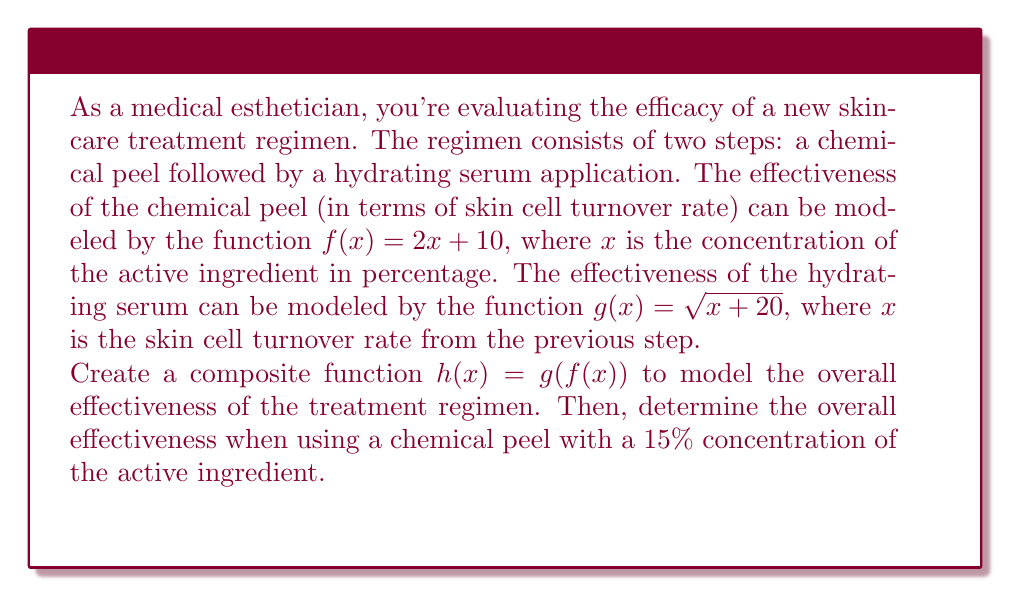What is the answer to this math problem? Let's approach this step-by-step:

1) We're given two functions:
   $f(x) = 2x + 10$ (chemical peel effectiveness)
   $g(x) = \sqrt{x + 20}$ (hydrating serum effectiveness)

2) We need to create a composite function $h(x) = g(f(x))$. This means we replace every $x$ in $g(x)$ with $f(x)$:

   $h(x) = g(f(x)) = \sqrt{f(x) + 20}$

3) Now, let's substitute $f(x)$ with its actual expression:

   $h(x) = \sqrt{(2x + 10) + 20} = \sqrt{2x + 30}$

4) This is our composite function that models the overall effectiveness of the treatment regimen.

5) To find the overall effectiveness when using a chemical peel with a 15% concentration, we need to calculate $h(15)$:

   $h(15) = \sqrt{2(15) + 30} = \sqrt{30 + 30} = \sqrt{60}$

6) Simplify:
   $\sqrt{60} = \sqrt{4 \cdot 15} = 2\sqrt{15} \approx 7.746$

Therefore, the overall effectiveness of the treatment regimen when using a chemical peel with a 15% concentration of the active ingredient is $2\sqrt{15}$, or approximately 7.746 on the effectiveness scale.
Answer: $2\sqrt{15}$ 